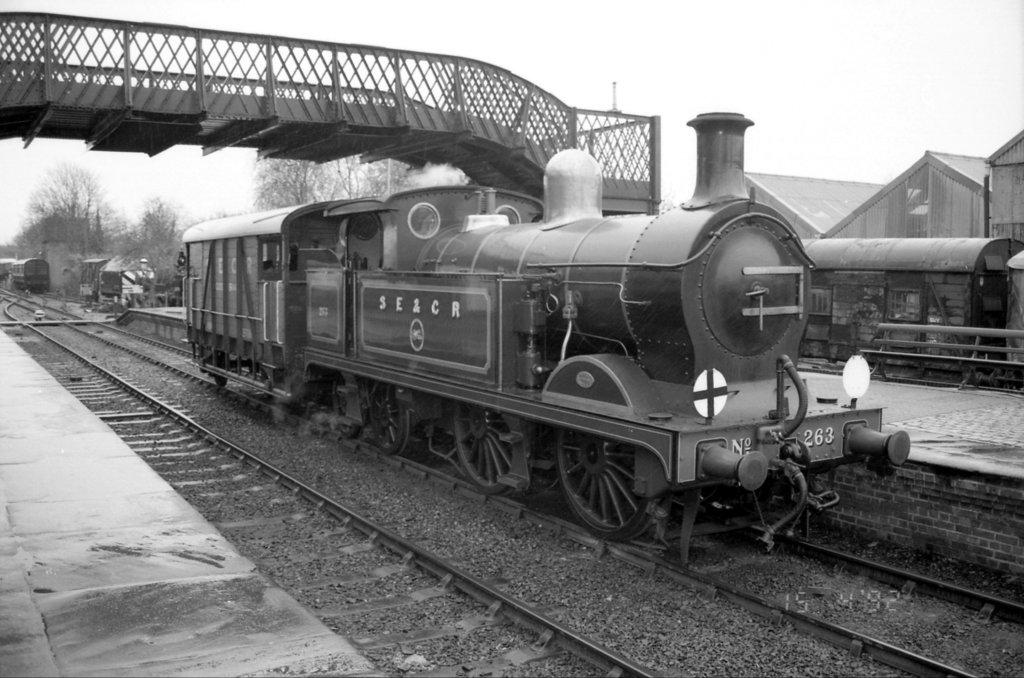What is the color scheme of the image? The image is black and white. What can be seen on the tracks in the image? There is a train on the tracks in the image. What connects the platforms in the image? There is a bridge connecting the platforms in the image. What structure is located beside the platform in the image? There is a building beside the platform in the image. How much does the peace symbol cost in the image? There is no peace symbol present in the image, so it is not possible to determine its cost. 